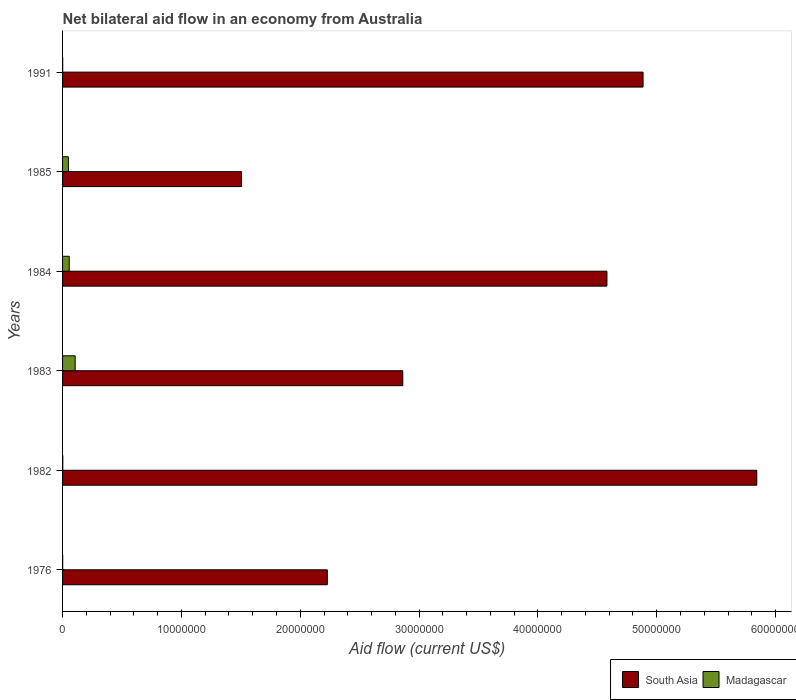How many different coloured bars are there?
Ensure brevity in your answer.  2. How many groups of bars are there?
Your answer should be compact. 6. Are the number of bars per tick equal to the number of legend labels?
Your answer should be compact. Yes. Are the number of bars on each tick of the Y-axis equal?
Your answer should be very brief. Yes. How many bars are there on the 6th tick from the top?
Provide a succinct answer. 2. What is the label of the 5th group of bars from the top?
Your answer should be very brief. 1982. In how many cases, is the number of bars for a given year not equal to the number of legend labels?
Offer a very short reply. 0. What is the net bilateral aid flow in Madagascar in 1976?
Offer a very short reply. 10000. Across all years, what is the maximum net bilateral aid flow in Madagascar?
Your answer should be very brief. 1.06e+06. Across all years, what is the minimum net bilateral aid flow in South Asia?
Provide a short and direct response. 1.51e+07. In which year was the net bilateral aid flow in Madagascar minimum?
Make the answer very short. 1976. What is the total net bilateral aid flow in Madagascar in the graph?
Ensure brevity in your answer.  2.15e+06. What is the difference between the net bilateral aid flow in South Asia in 1983 and that in 1991?
Provide a short and direct response. -2.02e+07. What is the difference between the net bilateral aid flow in Madagascar in 1983 and the net bilateral aid flow in South Asia in 1982?
Offer a terse response. -5.74e+07. What is the average net bilateral aid flow in Madagascar per year?
Give a very brief answer. 3.58e+05. In the year 1983, what is the difference between the net bilateral aid flow in Madagascar and net bilateral aid flow in South Asia?
Your answer should be very brief. -2.76e+07. What is the ratio of the net bilateral aid flow in Madagascar in 1982 to that in 1985?
Provide a succinct answer. 0.04. Is the difference between the net bilateral aid flow in Madagascar in 1976 and 1985 greater than the difference between the net bilateral aid flow in South Asia in 1976 and 1985?
Provide a succinct answer. No. What is the difference between the highest and the second highest net bilateral aid flow in South Asia?
Ensure brevity in your answer.  9.57e+06. What is the difference between the highest and the lowest net bilateral aid flow in Madagascar?
Keep it short and to the point. 1.05e+06. What does the 1st bar from the top in 1991 represents?
Provide a short and direct response. Madagascar. What does the 1st bar from the bottom in 1985 represents?
Offer a very short reply. South Asia. How many bars are there?
Ensure brevity in your answer.  12. What is the difference between two consecutive major ticks on the X-axis?
Ensure brevity in your answer.  1.00e+07. Does the graph contain any zero values?
Offer a very short reply. No. Where does the legend appear in the graph?
Make the answer very short. Bottom right. What is the title of the graph?
Offer a very short reply. Net bilateral aid flow in an economy from Australia. Does "Belarus" appear as one of the legend labels in the graph?
Make the answer very short. No. What is the label or title of the Y-axis?
Offer a terse response. Years. What is the Aid flow (current US$) in South Asia in 1976?
Ensure brevity in your answer.  2.23e+07. What is the Aid flow (current US$) of South Asia in 1982?
Offer a terse response. 5.84e+07. What is the Aid flow (current US$) of South Asia in 1983?
Offer a very short reply. 2.86e+07. What is the Aid flow (current US$) in Madagascar in 1983?
Provide a short and direct response. 1.06e+06. What is the Aid flow (current US$) of South Asia in 1984?
Ensure brevity in your answer.  4.58e+07. What is the Aid flow (current US$) of Madagascar in 1984?
Provide a succinct answer. 5.60e+05. What is the Aid flow (current US$) of South Asia in 1985?
Make the answer very short. 1.51e+07. What is the Aid flow (current US$) of Madagascar in 1985?
Offer a terse response. 4.90e+05. What is the Aid flow (current US$) of South Asia in 1991?
Your response must be concise. 4.88e+07. What is the Aid flow (current US$) in Madagascar in 1991?
Make the answer very short. 10000. Across all years, what is the maximum Aid flow (current US$) of South Asia?
Provide a short and direct response. 5.84e+07. Across all years, what is the maximum Aid flow (current US$) in Madagascar?
Offer a terse response. 1.06e+06. Across all years, what is the minimum Aid flow (current US$) of South Asia?
Provide a succinct answer. 1.51e+07. Across all years, what is the minimum Aid flow (current US$) in Madagascar?
Provide a short and direct response. 10000. What is the total Aid flow (current US$) in South Asia in the graph?
Make the answer very short. 2.19e+08. What is the total Aid flow (current US$) in Madagascar in the graph?
Offer a very short reply. 2.15e+06. What is the difference between the Aid flow (current US$) in South Asia in 1976 and that in 1982?
Keep it short and to the point. -3.61e+07. What is the difference between the Aid flow (current US$) of Madagascar in 1976 and that in 1982?
Provide a succinct answer. -10000. What is the difference between the Aid flow (current US$) in South Asia in 1976 and that in 1983?
Your answer should be very brief. -6.35e+06. What is the difference between the Aid flow (current US$) of Madagascar in 1976 and that in 1983?
Give a very brief answer. -1.05e+06. What is the difference between the Aid flow (current US$) of South Asia in 1976 and that in 1984?
Offer a very short reply. -2.35e+07. What is the difference between the Aid flow (current US$) in Madagascar in 1976 and that in 1984?
Keep it short and to the point. -5.50e+05. What is the difference between the Aid flow (current US$) in South Asia in 1976 and that in 1985?
Make the answer very short. 7.22e+06. What is the difference between the Aid flow (current US$) in Madagascar in 1976 and that in 1985?
Your response must be concise. -4.80e+05. What is the difference between the Aid flow (current US$) of South Asia in 1976 and that in 1991?
Offer a terse response. -2.66e+07. What is the difference between the Aid flow (current US$) in Madagascar in 1976 and that in 1991?
Provide a succinct answer. 0. What is the difference between the Aid flow (current US$) of South Asia in 1982 and that in 1983?
Make the answer very short. 2.98e+07. What is the difference between the Aid flow (current US$) of Madagascar in 1982 and that in 1983?
Your response must be concise. -1.04e+06. What is the difference between the Aid flow (current US$) of South Asia in 1982 and that in 1984?
Keep it short and to the point. 1.26e+07. What is the difference between the Aid flow (current US$) of Madagascar in 1982 and that in 1984?
Provide a short and direct response. -5.40e+05. What is the difference between the Aid flow (current US$) of South Asia in 1982 and that in 1985?
Offer a terse response. 4.34e+07. What is the difference between the Aid flow (current US$) of Madagascar in 1982 and that in 1985?
Provide a succinct answer. -4.70e+05. What is the difference between the Aid flow (current US$) of South Asia in 1982 and that in 1991?
Give a very brief answer. 9.57e+06. What is the difference between the Aid flow (current US$) in Madagascar in 1982 and that in 1991?
Your response must be concise. 10000. What is the difference between the Aid flow (current US$) of South Asia in 1983 and that in 1984?
Offer a very short reply. -1.72e+07. What is the difference between the Aid flow (current US$) of South Asia in 1983 and that in 1985?
Keep it short and to the point. 1.36e+07. What is the difference between the Aid flow (current US$) of Madagascar in 1983 and that in 1985?
Ensure brevity in your answer.  5.70e+05. What is the difference between the Aid flow (current US$) of South Asia in 1983 and that in 1991?
Make the answer very short. -2.02e+07. What is the difference between the Aid flow (current US$) of Madagascar in 1983 and that in 1991?
Provide a short and direct response. 1.05e+06. What is the difference between the Aid flow (current US$) of South Asia in 1984 and that in 1985?
Your response must be concise. 3.08e+07. What is the difference between the Aid flow (current US$) of South Asia in 1984 and that in 1991?
Offer a terse response. -3.04e+06. What is the difference between the Aid flow (current US$) of South Asia in 1985 and that in 1991?
Your response must be concise. -3.38e+07. What is the difference between the Aid flow (current US$) of Madagascar in 1985 and that in 1991?
Ensure brevity in your answer.  4.80e+05. What is the difference between the Aid flow (current US$) of South Asia in 1976 and the Aid flow (current US$) of Madagascar in 1982?
Offer a very short reply. 2.23e+07. What is the difference between the Aid flow (current US$) of South Asia in 1976 and the Aid flow (current US$) of Madagascar in 1983?
Keep it short and to the point. 2.12e+07. What is the difference between the Aid flow (current US$) in South Asia in 1976 and the Aid flow (current US$) in Madagascar in 1984?
Give a very brief answer. 2.17e+07. What is the difference between the Aid flow (current US$) in South Asia in 1976 and the Aid flow (current US$) in Madagascar in 1985?
Offer a terse response. 2.18e+07. What is the difference between the Aid flow (current US$) of South Asia in 1976 and the Aid flow (current US$) of Madagascar in 1991?
Offer a very short reply. 2.23e+07. What is the difference between the Aid flow (current US$) of South Asia in 1982 and the Aid flow (current US$) of Madagascar in 1983?
Your answer should be compact. 5.74e+07. What is the difference between the Aid flow (current US$) of South Asia in 1982 and the Aid flow (current US$) of Madagascar in 1984?
Give a very brief answer. 5.79e+07. What is the difference between the Aid flow (current US$) in South Asia in 1982 and the Aid flow (current US$) in Madagascar in 1985?
Your response must be concise. 5.79e+07. What is the difference between the Aid flow (current US$) in South Asia in 1982 and the Aid flow (current US$) in Madagascar in 1991?
Provide a short and direct response. 5.84e+07. What is the difference between the Aid flow (current US$) in South Asia in 1983 and the Aid flow (current US$) in Madagascar in 1984?
Offer a very short reply. 2.81e+07. What is the difference between the Aid flow (current US$) of South Asia in 1983 and the Aid flow (current US$) of Madagascar in 1985?
Your response must be concise. 2.81e+07. What is the difference between the Aid flow (current US$) in South Asia in 1983 and the Aid flow (current US$) in Madagascar in 1991?
Your answer should be compact. 2.86e+07. What is the difference between the Aid flow (current US$) in South Asia in 1984 and the Aid flow (current US$) in Madagascar in 1985?
Give a very brief answer. 4.53e+07. What is the difference between the Aid flow (current US$) of South Asia in 1984 and the Aid flow (current US$) of Madagascar in 1991?
Provide a short and direct response. 4.58e+07. What is the difference between the Aid flow (current US$) of South Asia in 1985 and the Aid flow (current US$) of Madagascar in 1991?
Make the answer very short. 1.50e+07. What is the average Aid flow (current US$) of South Asia per year?
Offer a very short reply. 3.65e+07. What is the average Aid flow (current US$) of Madagascar per year?
Ensure brevity in your answer.  3.58e+05. In the year 1976, what is the difference between the Aid flow (current US$) of South Asia and Aid flow (current US$) of Madagascar?
Make the answer very short. 2.23e+07. In the year 1982, what is the difference between the Aid flow (current US$) of South Asia and Aid flow (current US$) of Madagascar?
Your response must be concise. 5.84e+07. In the year 1983, what is the difference between the Aid flow (current US$) of South Asia and Aid flow (current US$) of Madagascar?
Your response must be concise. 2.76e+07. In the year 1984, what is the difference between the Aid flow (current US$) of South Asia and Aid flow (current US$) of Madagascar?
Your response must be concise. 4.52e+07. In the year 1985, what is the difference between the Aid flow (current US$) of South Asia and Aid flow (current US$) of Madagascar?
Ensure brevity in your answer.  1.46e+07. In the year 1991, what is the difference between the Aid flow (current US$) of South Asia and Aid flow (current US$) of Madagascar?
Offer a very short reply. 4.88e+07. What is the ratio of the Aid flow (current US$) in South Asia in 1976 to that in 1982?
Provide a succinct answer. 0.38. What is the ratio of the Aid flow (current US$) of South Asia in 1976 to that in 1983?
Offer a terse response. 0.78. What is the ratio of the Aid flow (current US$) of Madagascar in 1976 to that in 1983?
Ensure brevity in your answer.  0.01. What is the ratio of the Aid flow (current US$) in South Asia in 1976 to that in 1984?
Your answer should be very brief. 0.49. What is the ratio of the Aid flow (current US$) in Madagascar in 1976 to that in 1984?
Keep it short and to the point. 0.02. What is the ratio of the Aid flow (current US$) of South Asia in 1976 to that in 1985?
Make the answer very short. 1.48. What is the ratio of the Aid flow (current US$) in Madagascar in 1976 to that in 1985?
Make the answer very short. 0.02. What is the ratio of the Aid flow (current US$) of South Asia in 1976 to that in 1991?
Provide a short and direct response. 0.46. What is the ratio of the Aid flow (current US$) of Madagascar in 1976 to that in 1991?
Your response must be concise. 1. What is the ratio of the Aid flow (current US$) in South Asia in 1982 to that in 1983?
Your answer should be compact. 2.04. What is the ratio of the Aid flow (current US$) in Madagascar in 1982 to that in 1983?
Your response must be concise. 0.02. What is the ratio of the Aid flow (current US$) in South Asia in 1982 to that in 1984?
Provide a succinct answer. 1.28. What is the ratio of the Aid flow (current US$) in Madagascar in 1982 to that in 1984?
Keep it short and to the point. 0.04. What is the ratio of the Aid flow (current US$) of South Asia in 1982 to that in 1985?
Give a very brief answer. 3.88. What is the ratio of the Aid flow (current US$) of Madagascar in 1982 to that in 1985?
Ensure brevity in your answer.  0.04. What is the ratio of the Aid flow (current US$) in South Asia in 1982 to that in 1991?
Keep it short and to the point. 1.2. What is the ratio of the Aid flow (current US$) of Madagascar in 1983 to that in 1984?
Your answer should be compact. 1.89. What is the ratio of the Aid flow (current US$) in South Asia in 1983 to that in 1985?
Offer a terse response. 1.9. What is the ratio of the Aid flow (current US$) of Madagascar in 1983 to that in 1985?
Keep it short and to the point. 2.16. What is the ratio of the Aid flow (current US$) of South Asia in 1983 to that in 1991?
Offer a terse response. 0.59. What is the ratio of the Aid flow (current US$) in Madagascar in 1983 to that in 1991?
Give a very brief answer. 106. What is the ratio of the Aid flow (current US$) in South Asia in 1984 to that in 1985?
Offer a terse response. 3.04. What is the ratio of the Aid flow (current US$) of South Asia in 1984 to that in 1991?
Make the answer very short. 0.94. What is the ratio of the Aid flow (current US$) of Madagascar in 1984 to that in 1991?
Your answer should be compact. 56. What is the ratio of the Aid flow (current US$) of South Asia in 1985 to that in 1991?
Your answer should be compact. 0.31. What is the difference between the highest and the second highest Aid flow (current US$) of South Asia?
Give a very brief answer. 9.57e+06. What is the difference between the highest and the second highest Aid flow (current US$) of Madagascar?
Your answer should be compact. 5.00e+05. What is the difference between the highest and the lowest Aid flow (current US$) in South Asia?
Keep it short and to the point. 4.34e+07. What is the difference between the highest and the lowest Aid flow (current US$) in Madagascar?
Your answer should be very brief. 1.05e+06. 